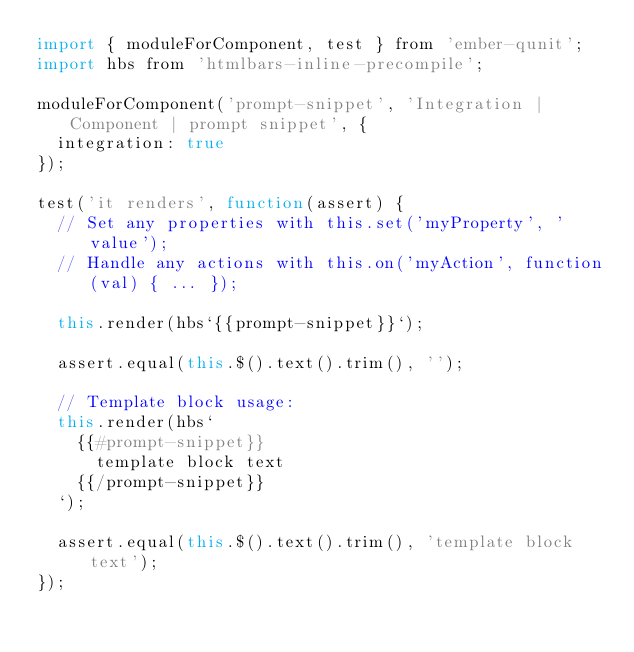<code> <loc_0><loc_0><loc_500><loc_500><_JavaScript_>import { moduleForComponent, test } from 'ember-qunit';
import hbs from 'htmlbars-inline-precompile';

moduleForComponent('prompt-snippet', 'Integration | Component | prompt snippet', {
  integration: true
});

test('it renders', function(assert) {
  // Set any properties with this.set('myProperty', 'value');
  // Handle any actions with this.on('myAction', function(val) { ... });

  this.render(hbs`{{prompt-snippet}}`);

  assert.equal(this.$().text().trim(), '');

  // Template block usage:
  this.render(hbs`
    {{#prompt-snippet}}
      template block text
    {{/prompt-snippet}}
  `);

  assert.equal(this.$().text().trim(), 'template block text');
});
</code> 